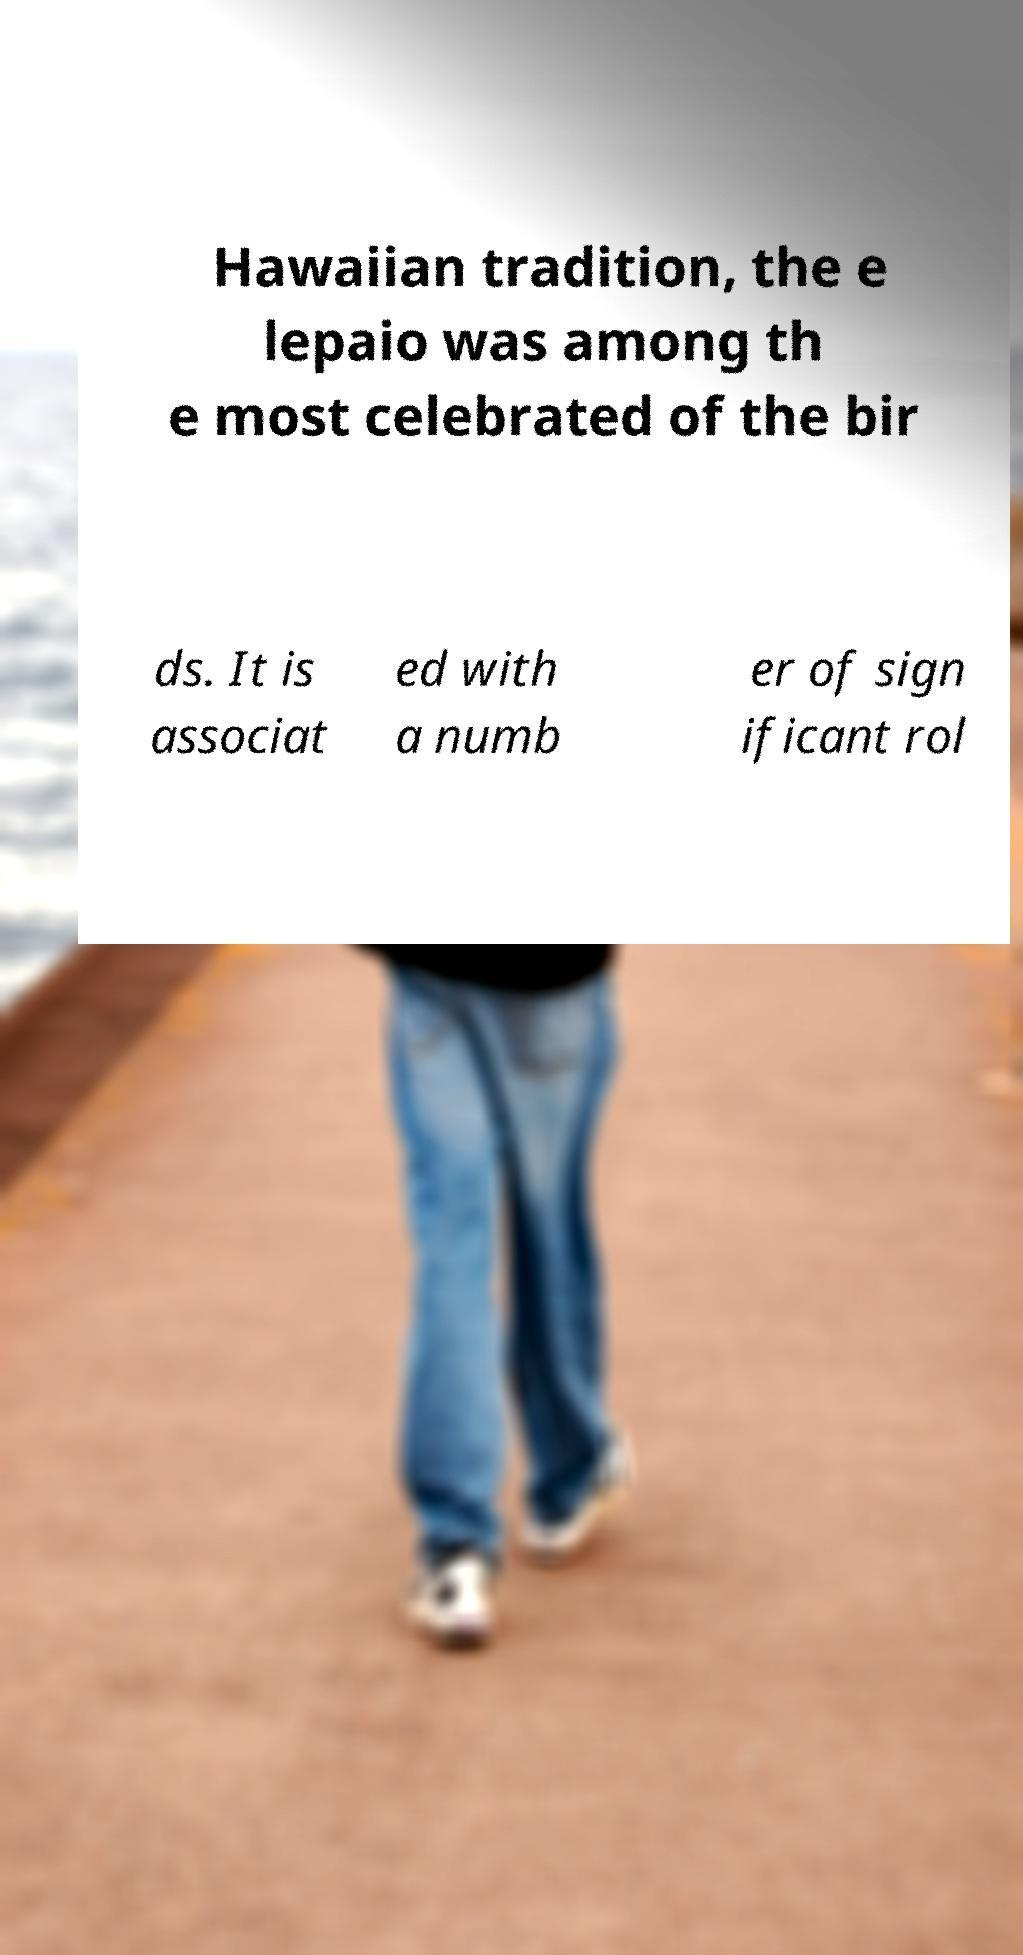I need the written content from this picture converted into text. Can you do that? Hawaiian tradition, the e lepaio was among th e most celebrated of the bir ds. It is associat ed with a numb er of sign ificant rol 